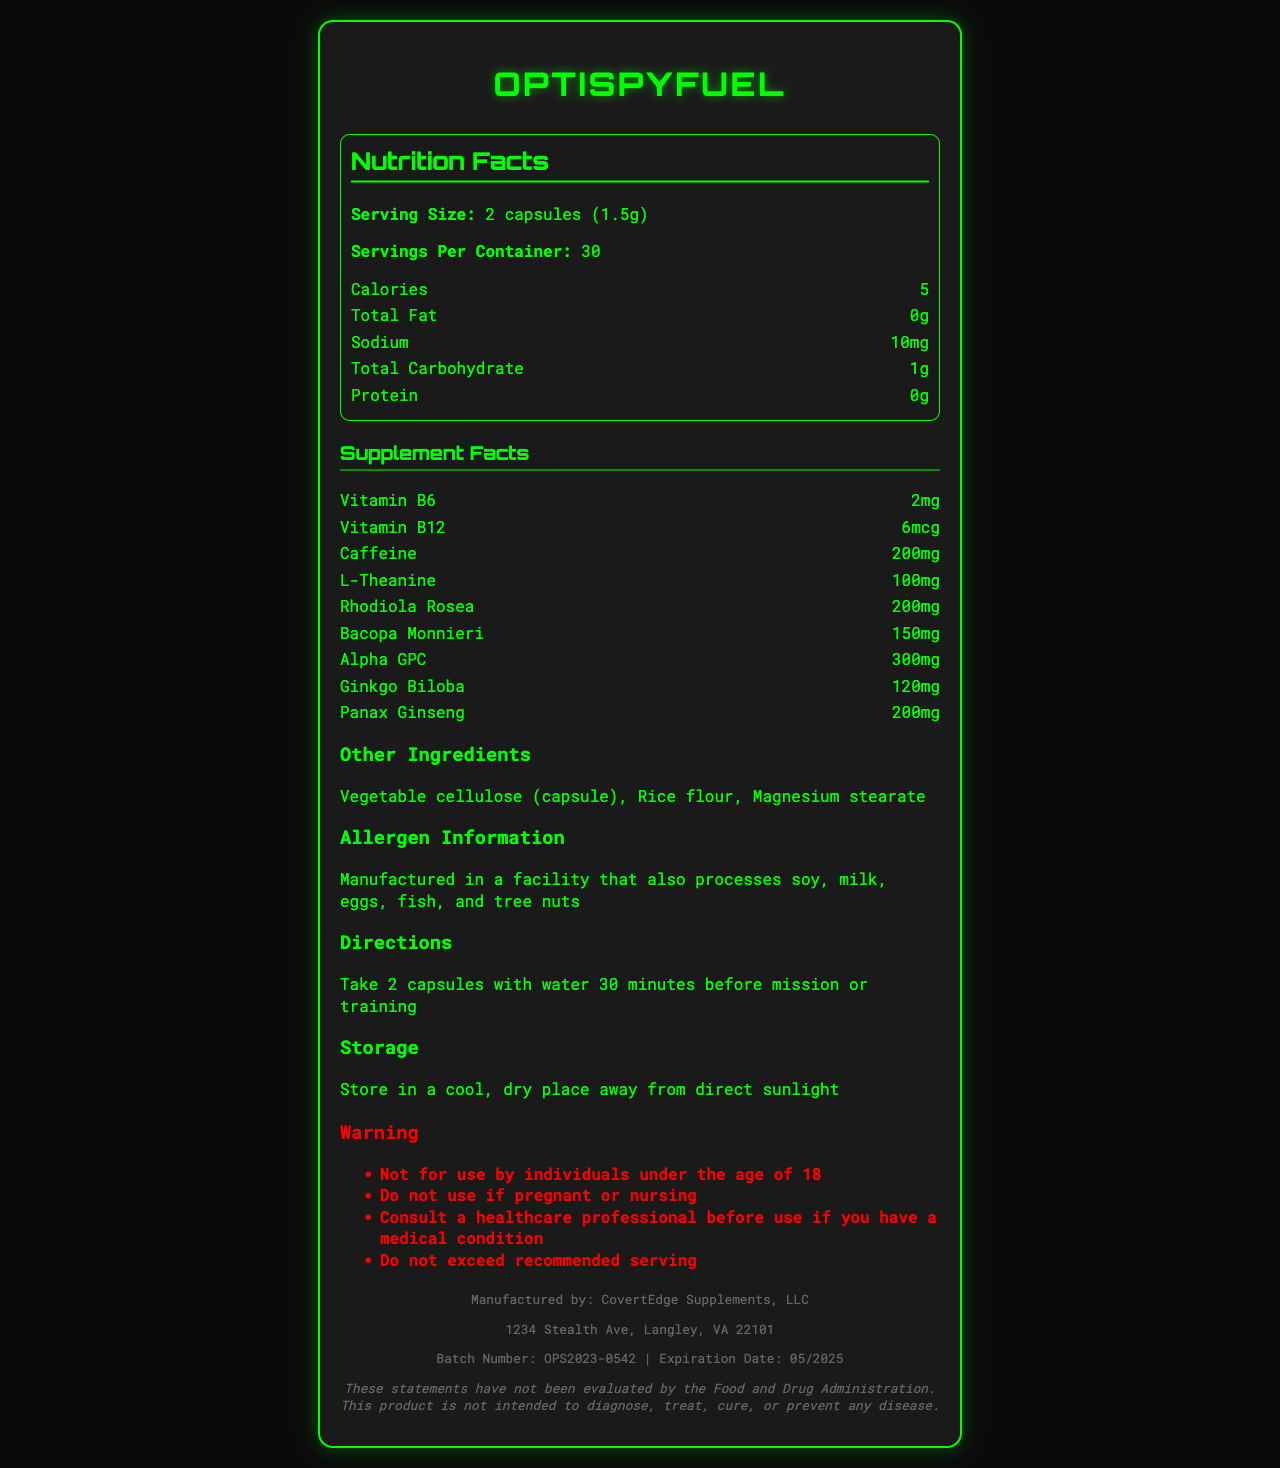What is the serving size for OptiSpyFuel? The document lists the serving size as "2 capsules (1.5g)".
Answer: 2 capsules (1.5g) How many servings are there per container? The servings per container is specified as 30 in the document.
Answer: 30 How many calories are in one serving of OptiSpyFuel? The nutrition facts indicate that there are 5 calories per serving.
Answer: 5 What is the amount of caffeine in one serving? The supplement facts section shows that one serving contains 200mg of caffeine.
Answer: 200mg What is the vitamin B6 content in one serving? The document lists Vitamin B6 content as 2mg per serving.
Answer: 2mg Which ingredient is present in the highest quantity? A. Ginkgo Biloba B. Alpha GPC C. Bacopa Monnieri Alpha GPC is listed with 300mg, which is the highest quantity among the ingredients mentioned.
Answer: B What is the sodium content per serving of OptiSpyFuel? The nutrition facts indicate that there is 10mg of sodium per serving.
Answer: 10mg How many grams of protein are in each serving? The document clearly states that there is 0g of protein per serving.
Answer: 0g Is this supplement safe for individuals under the age of 18 to use? One of the warnings explicitly states, "Not for use by individuals under the age of 18."
Answer: No Which of the following ingredients is not included in OptiSpyFuel? 1. Panax Ginseng 2. L-Theanine 3. Ascorbic Acid 4. Rhodiola Rosea The only ingredient not listed in the document is Ascorbic Acid.
Answer: 3. Ascorbic Acid Does the label mention any allergens that may be present in the manufacturing facility? The allergen information states it is "Manufactured in a facility that also processes soy, milk, eggs, fish, and tree nuts."
Answer: Yes Summarize the main purpose of the document. The document primarily focuses on delivering all necessary information about the OptiSpyFuel product, including nutritional values, ingredients, usage directions, allergen warnings, manufacturer details, storage instructions, and warnings about its use.
Answer: The document provides detailed nutritional information and supplement facts for OptiSpyFuel, a performance-enhancing supplement designed for undercover operatives. It includes serving size, servings per container, calorie count, and other nutritional contents, along with a list of ingredients and allergens. What is the expiration date of the product? The expiration date is mentioned at the bottom of the document as 05/2025.
Answer: 05/2025 What specific benefit does Bacopa Monnieri provide according to the document? The document lists Bacopa Monnieri as an ingredient but does not specify its benefits.
Answer: Cannot be determined What is the recommended way to take OptiSpyFuel for best results? The document advises taking 2 capsules with water 30 minutes before mission or training for optimal results.
Answer: Take 2 capsules with water 30 minutes before mission or training Who is the manufacturer of OptiSpyFuel? The manufacturer is listed as CovertEdge Supplements, LLC.
Answer: CovertEdge Supplements, LLC What storage condition is recommended for OptiSpyFuel? The document recommends storing the supplement in a cool, dry place away from direct sunlight to maintain its efficacy.
Answer: Store in a cool, dry place away from direct sunlight 